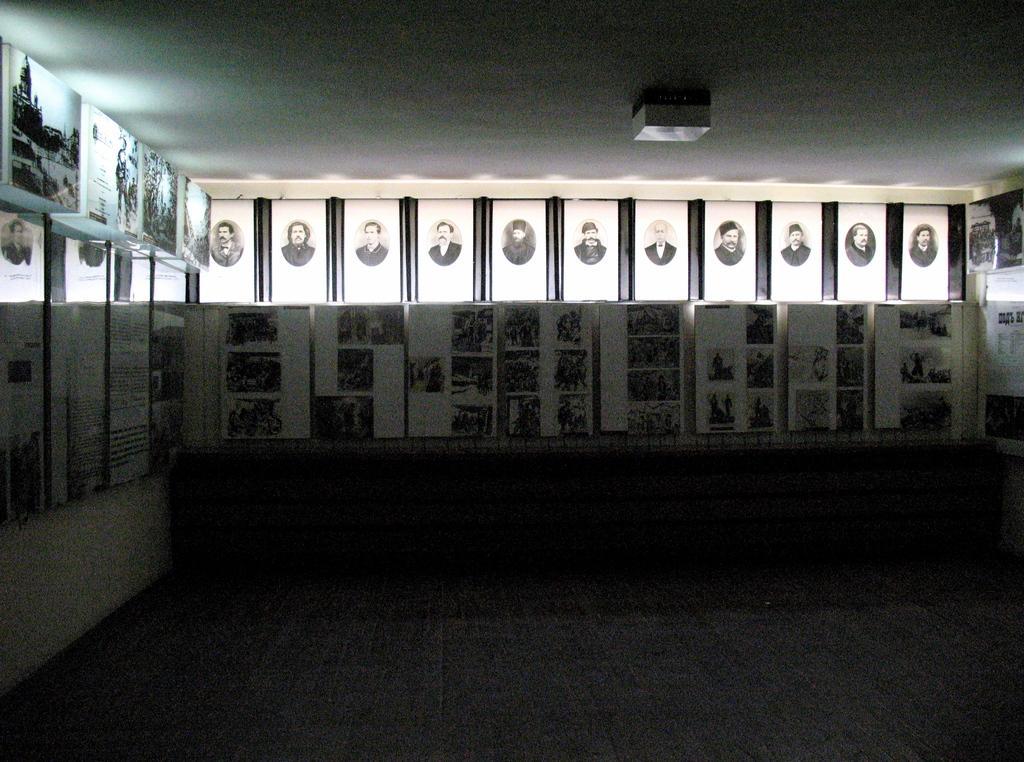In one or two sentences, can you explain what this image depicts? This is an inside view of a room. Here I can see many photo frames are attached to the walls. 